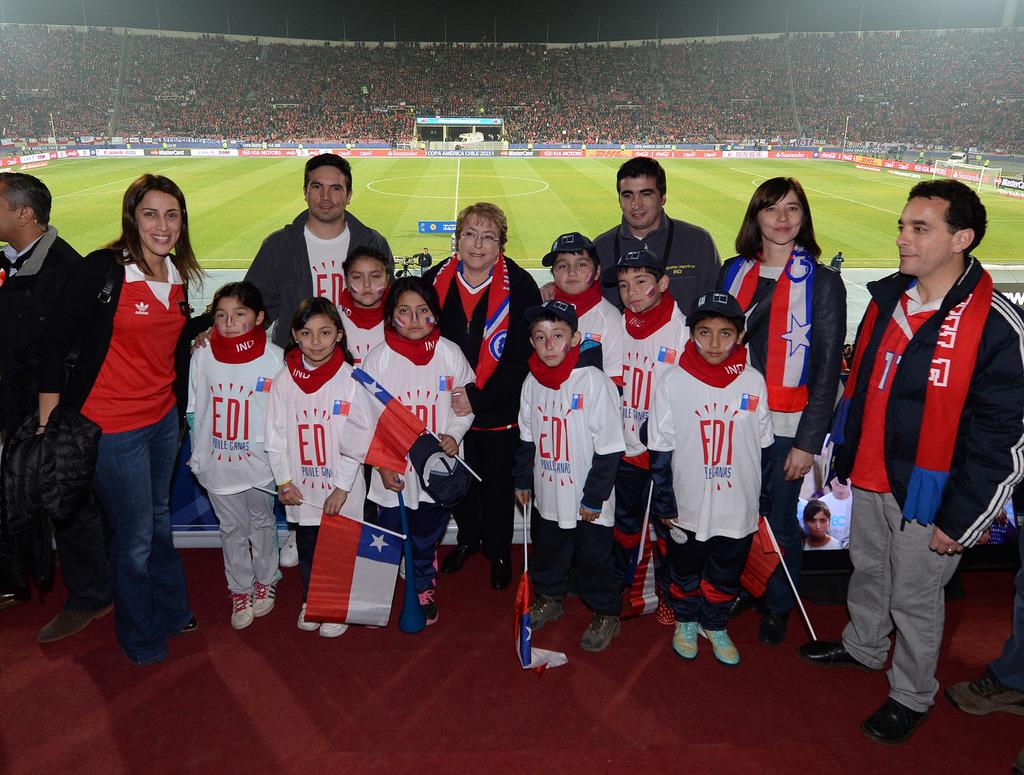What team do the children play for?
Provide a short and direct response. Edi. What initials are on the children's white shirts?
Make the answer very short. Edi. 